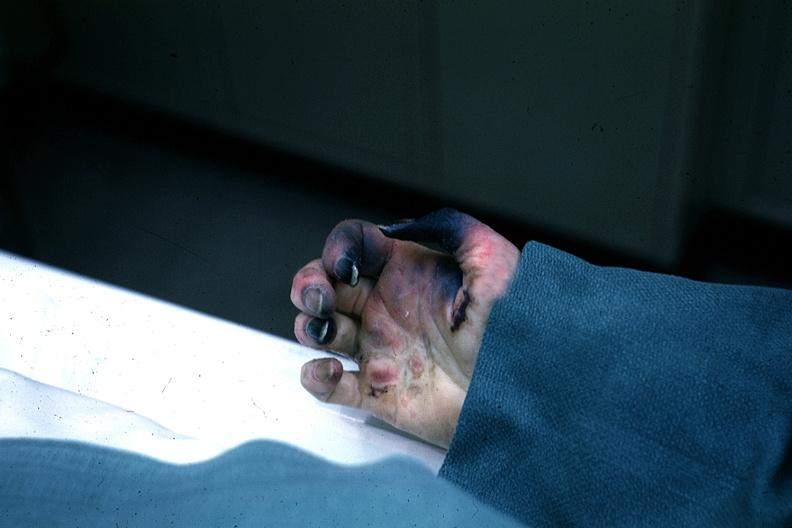why does this image show excellent gangrenous necrosis of fingers said to be?
Answer the question using a single word or phrase. Due embolism 